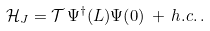<formula> <loc_0><loc_0><loc_500><loc_500>\mathcal { H } _ { J } = \mathcal { T } \, \Psi ^ { \dagger } ( L ) \Psi ( 0 ) \, + \, h . c . \, .</formula> 